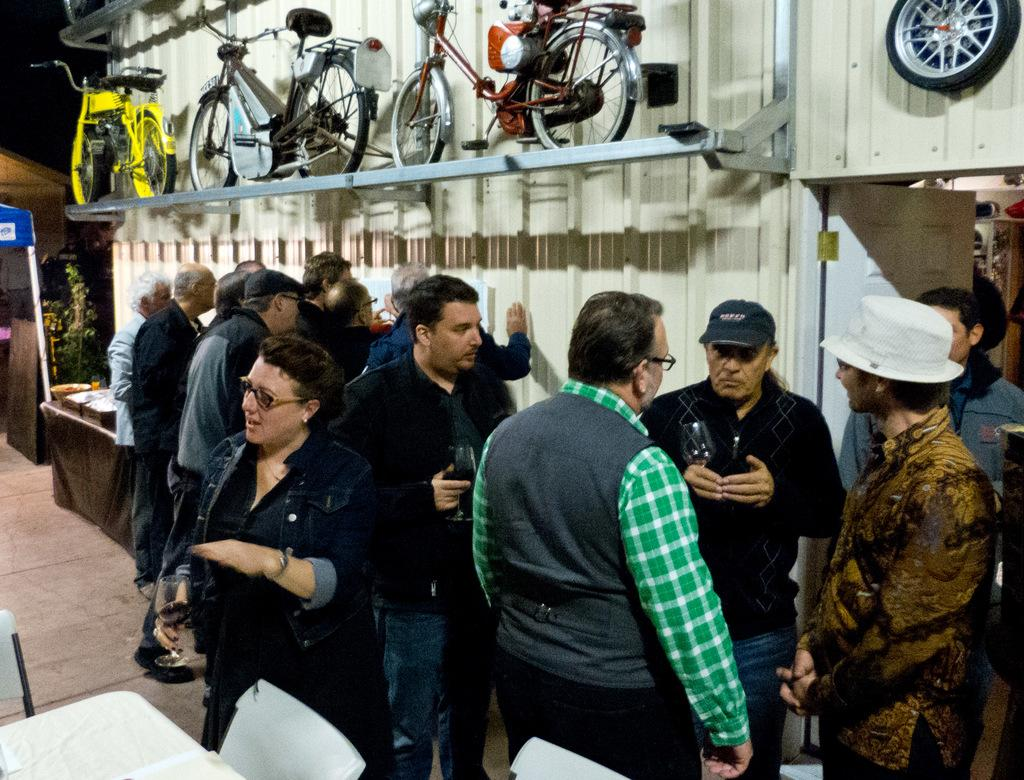What can be seen in the image? There are people standing in the image, and there are bicycles present as well. Can you describe the people in the image? The facts provided do not give specific details about the people, but we know they are standing. What are the bicycles doing in the image? The facts provided do not give specific details about the bicycles, but we know they are present in the image. What flavor of shade can be seen in the image? There is no shade present in the image, and therefore no flavor can be associated with it. 